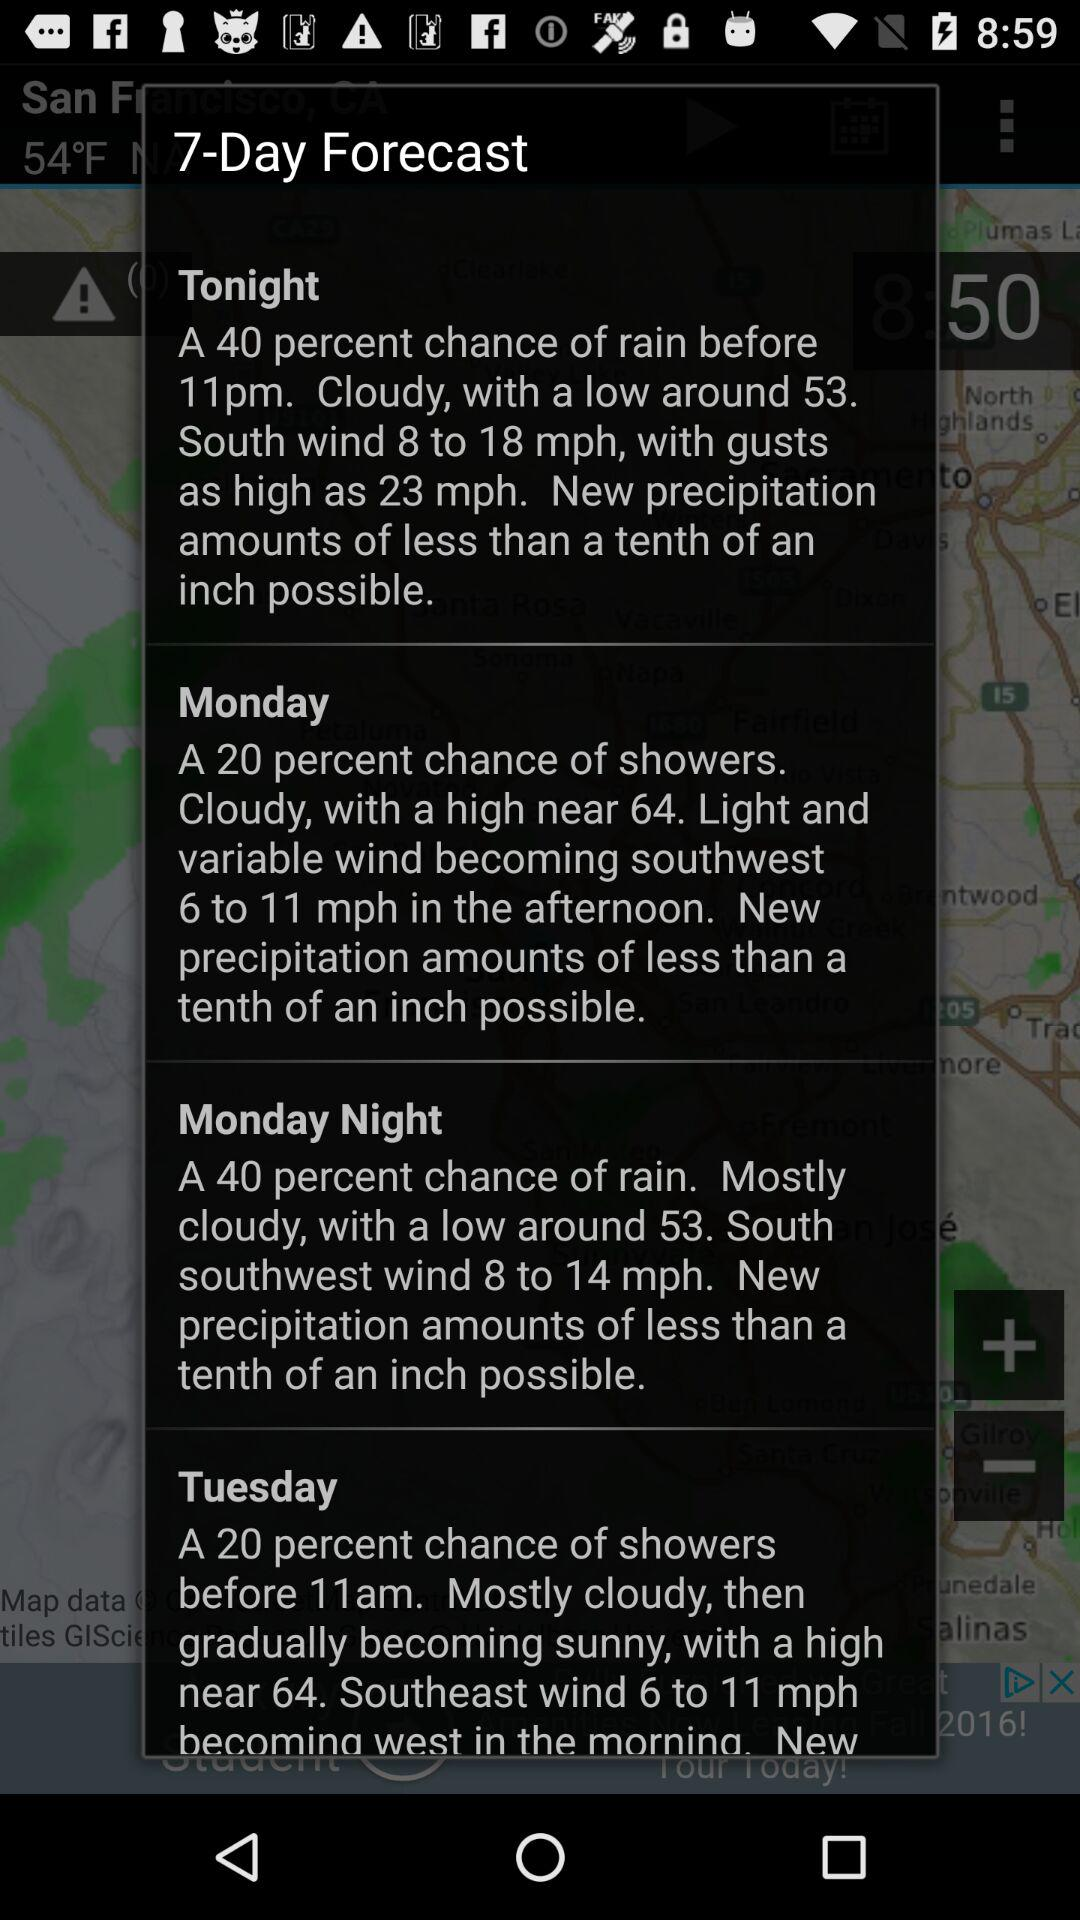How many days are predicted to have rain?
Answer the question using a single word or phrase. 2 